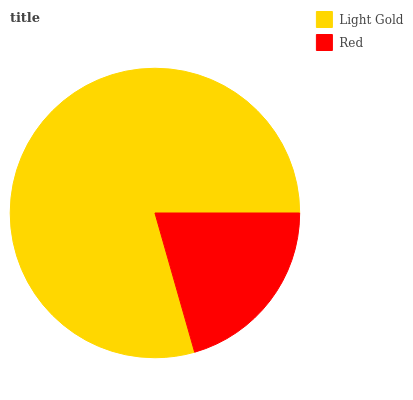Is Red the minimum?
Answer yes or no. Yes. Is Light Gold the maximum?
Answer yes or no. Yes. Is Red the maximum?
Answer yes or no. No. Is Light Gold greater than Red?
Answer yes or no. Yes. Is Red less than Light Gold?
Answer yes or no. Yes. Is Red greater than Light Gold?
Answer yes or no. No. Is Light Gold less than Red?
Answer yes or no. No. Is Light Gold the high median?
Answer yes or no. Yes. Is Red the low median?
Answer yes or no. Yes. Is Red the high median?
Answer yes or no. No. Is Light Gold the low median?
Answer yes or no. No. 